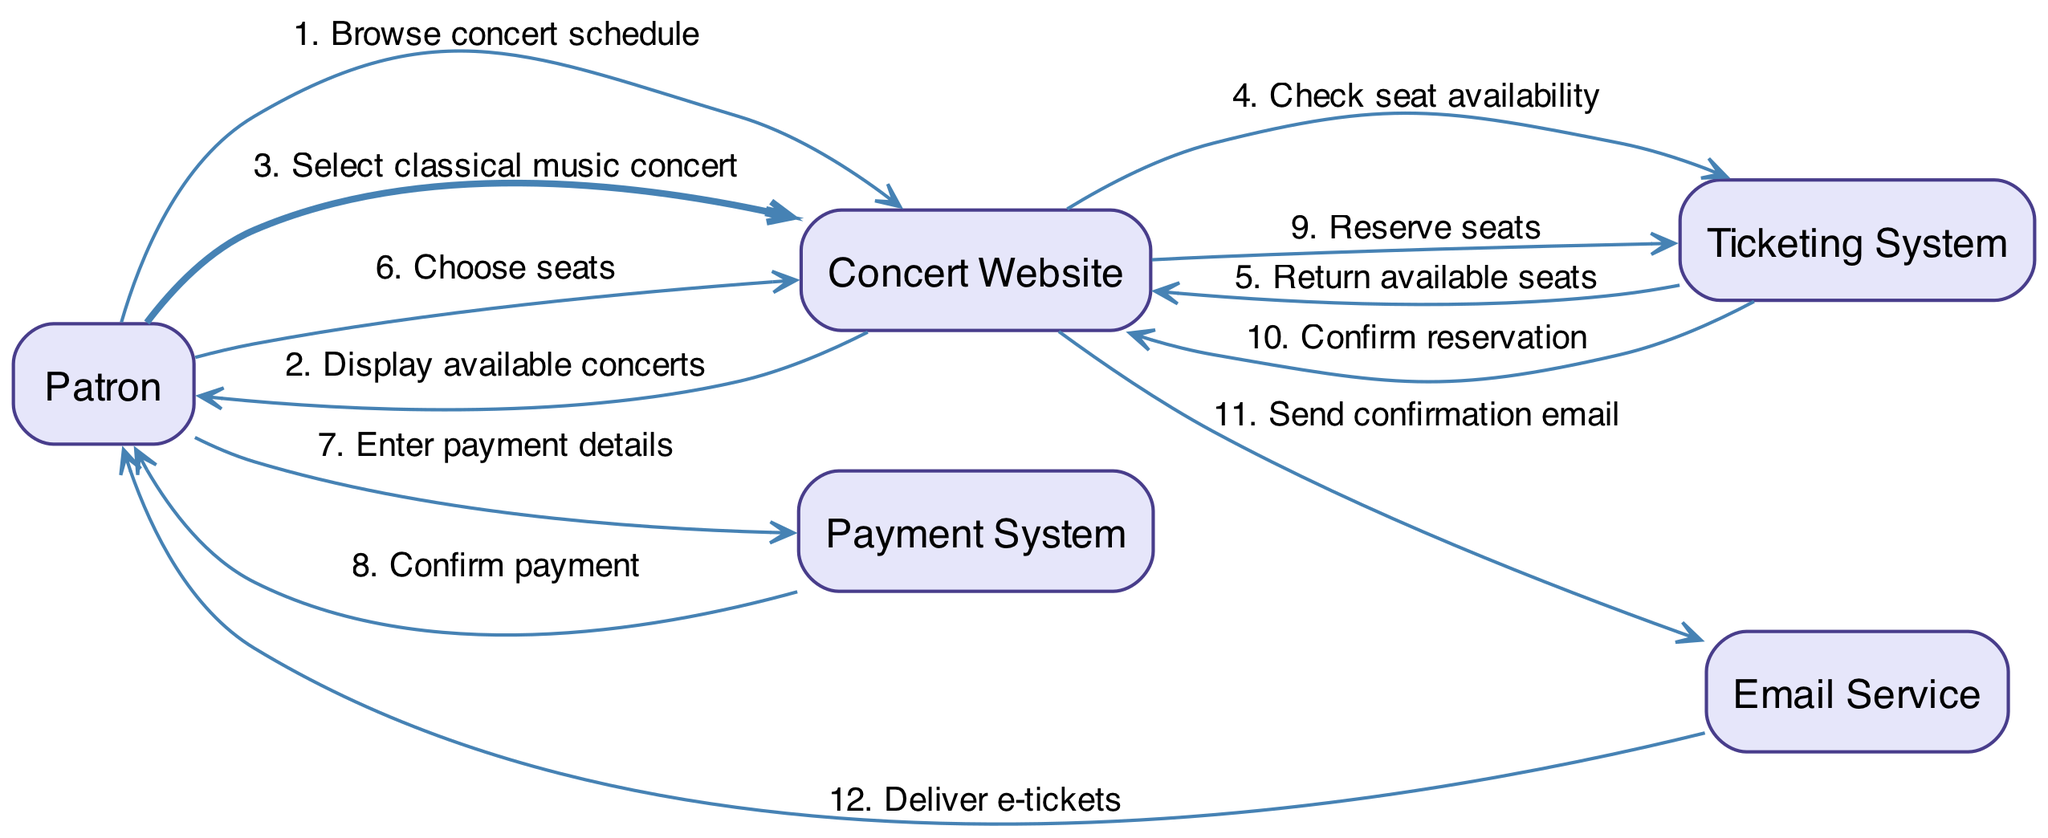What is the first action taken by the Patron? The Patron initiates the process by browsing the concert schedule, which is the first action indicated in the diagram.
Answer: Browse concert schedule How many actions are there in the diagram? By counting the individual actions listed in the diagram from the Patron through to the Email Service, there are a total of 12 actions.
Answer: 12 Which actor is responsible for confirming the payment? The diagram indicates that the Payment System confirms the payment after the Patron enters their payment details.
Answer: Payment System What is the outcome after the Ticketing System confirms the reservation? After the Ticketing System confirms the reservation, the Concert Website sends a confirmation email, which is the next action in the sequence.
Answer: Send confirmation email Which actor does the Patron interact with to enter payment details? The Patron directly interacts with the Payment System to enter their payment details as shown by the action flow in the diagram.
Answer: Payment System How do the available seats get returned to the Concert Website? The Ticketing System returns the available seats back to the Concert Website after checking seat availability, which represents a flow of information in the booking process.
Answer: Return available seats What is the last action shown in the sequence diagram? The last action in the sequence is the Email Service delivering the e-tickets to the Patron, completing the booking process.
Answer: Deliver e-tickets Which two actors are involved in the action of checking seat availability? The action of checking seat availability involves the Concert Website and the Ticketing System based on the flow depicted in the diagram.
Answer: Concert Website and Ticketing System How many different actors are involved in the booking process? By examining the diagram, there are five unique actors involved in the booking process: Patron, Concert Website, Payment System, Ticketing System, and Email Service.
Answer: 5 